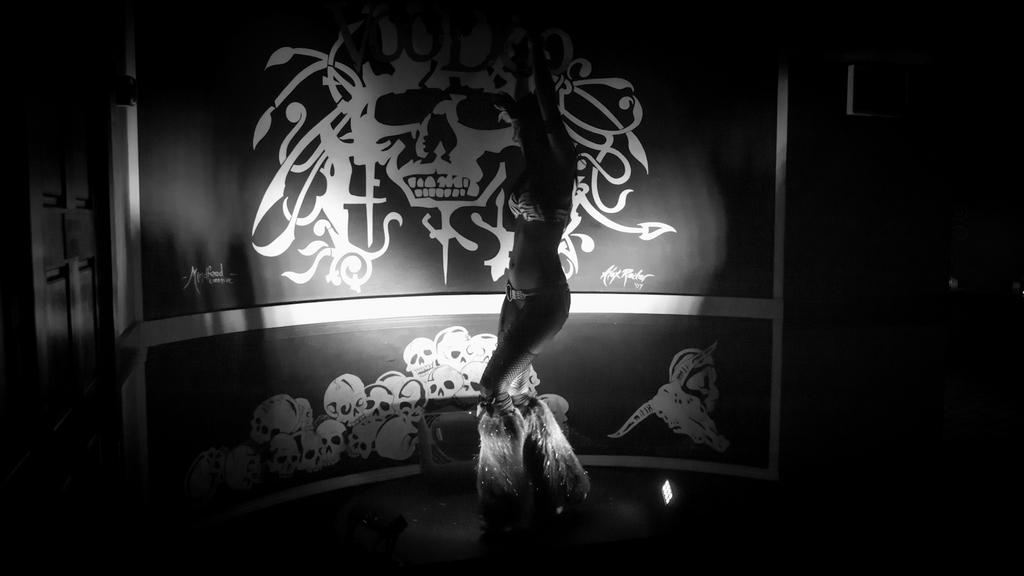What is the overall appearance of the image? The image has a dark appearance. What is the person in the image doing? There is a person dancing in the image. What can be seen in the background of the image? There is a poster with text and images in the background of the image. What type of current can be seen flowing through the image? There is no current visible in the image, as it features a person dancing and a poster in the background. 